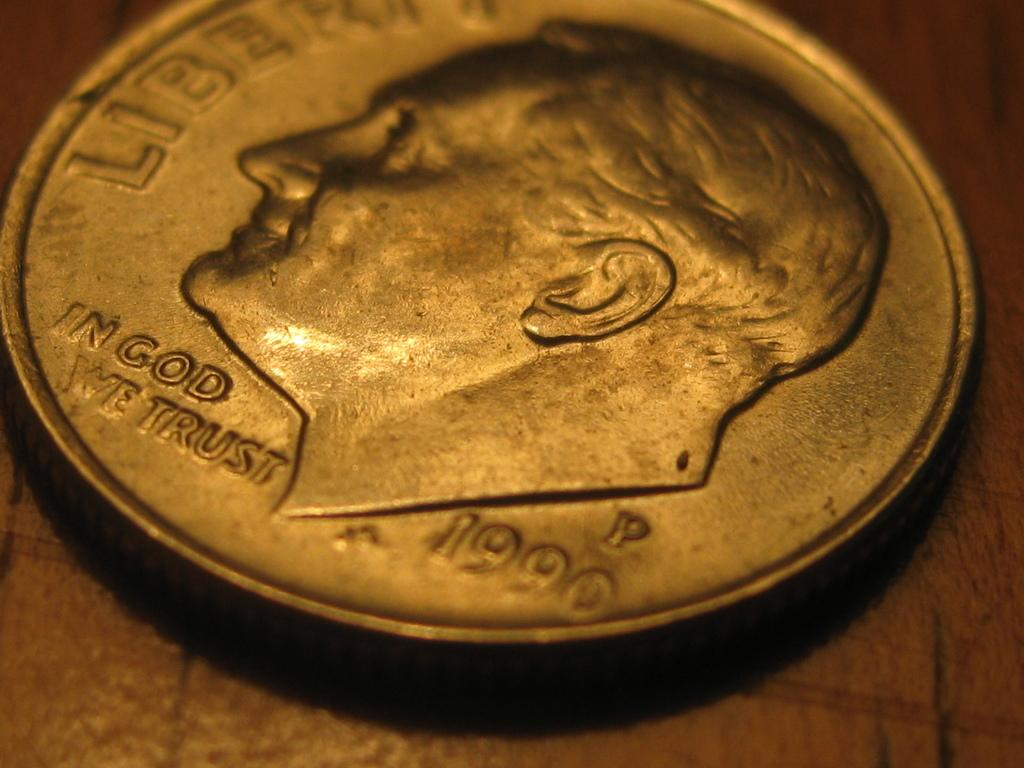What object can be seen in the image? There is a coin in the image. On what type of surface is the coin placed? The coin is placed on a wooden surface. What can be found on the coin? There is text and a human figure on the coin. What scent can be detected from the coin in the image? There is no mention of a scent associated with the coin in the image. 